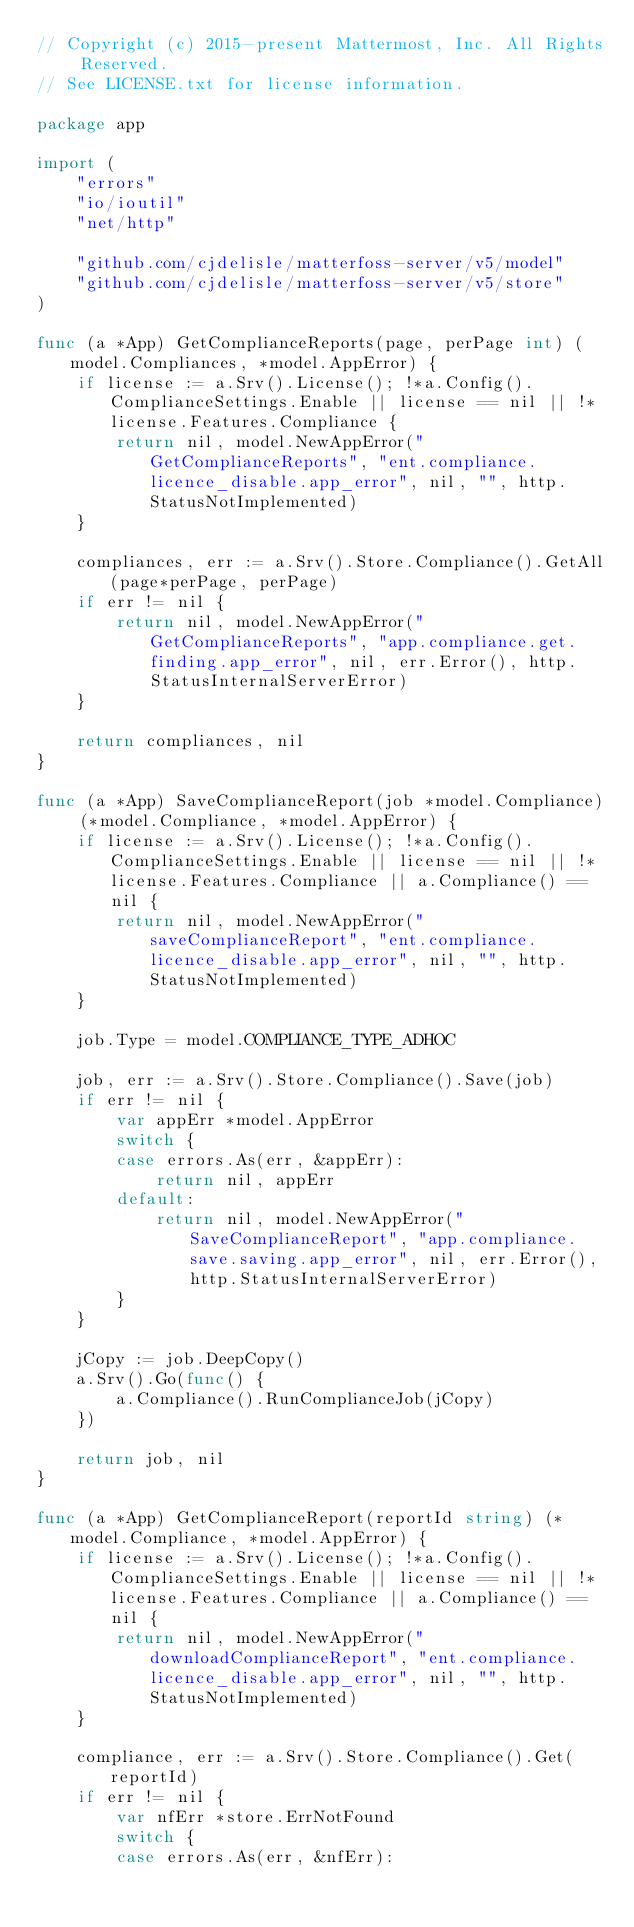<code> <loc_0><loc_0><loc_500><loc_500><_Go_>// Copyright (c) 2015-present Mattermost, Inc. All Rights Reserved.
// See LICENSE.txt for license information.

package app

import (
	"errors"
	"io/ioutil"
	"net/http"

	"github.com/cjdelisle/matterfoss-server/v5/model"
	"github.com/cjdelisle/matterfoss-server/v5/store"
)

func (a *App) GetComplianceReports(page, perPage int) (model.Compliances, *model.AppError) {
	if license := a.Srv().License(); !*a.Config().ComplianceSettings.Enable || license == nil || !*license.Features.Compliance {
		return nil, model.NewAppError("GetComplianceReports", "ent.compliance.licence_disable.app_error", nil, "", http.StatusNotImplemented)
	}

	compliances, err := a.Srv().Store.Compliance().GetAll(page*perPage, perPage)
	if err != nil {
		return nil, model.NewAppError("GetComplianceReports", "app.compliance.get.finding.app_error", nil, err.Error(), http.StatusInternalServerError)
	}

	return compliances, nil
}

func (a *App) SaveComplianceReport(job *model.Compliance) (*model.Compliance, *model.AppError) {
	if license := a.Srv().License(); !*a.Config().ComplianceSettings.Enable || license == nil || !*license.Features.Compliance || a.Compliance() == nil {
		return nil, model.NewAppError("saveComplianceReport", "ent.compliance.licence_disable.app_error", nil, "", http.StatusNotImplemented)
	}

	job.Type = model.COMPLIANCE_TYPE_ADHOC

	job, err := a.Srv().Store.Compliance().Save(job)
	if err != nil {
		var appErr *model.AppError
		switch {
		case errors.As(err, &appErr):
			return nil, appErr
		default:
			return nil, model.NewAppError("SaveComplianceReport", "app.compliance.save.saving.app_error", nil, err.Error(), http.StatusInternalServerError)
		}
	}

	jCopy := job.DeepCopy()
	a.Srv().Go(func() {
		a.Compliance().RunComplianceJob(jCopy)
	})

	return job, nil
}

func (a *App) GetComplianceReport(reportId string) (*model.Compliance, *model.AppError) {
	if license := a.Srv().License(); !*a.Config().ComplianceSettings.Enable || license == nil || !*license.Features.Compliance || a.Compliance() == nil {
		return nil, model.NewAppError("downloadComplianceReport", "ent.compliance.licence_disable.app_error", nil, "", http.StatusNotImplemented)
	}

	compliance, err := a.Srv().Store.Compliance().Get(reportId)
	if err != nil {
		var nfErr *store.ErrNotFound
		switch {
		case errors.As(err, &nfErr):</code> 